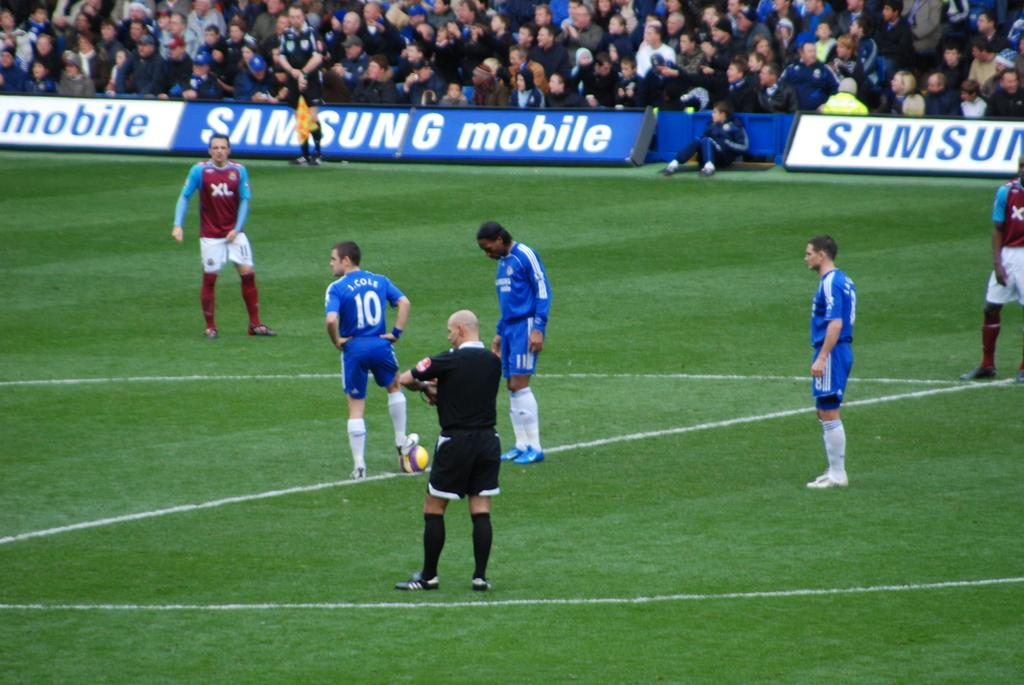<image>
Create a compact narrative representing the image presented. soccer players on a field in front of a samsung banner 